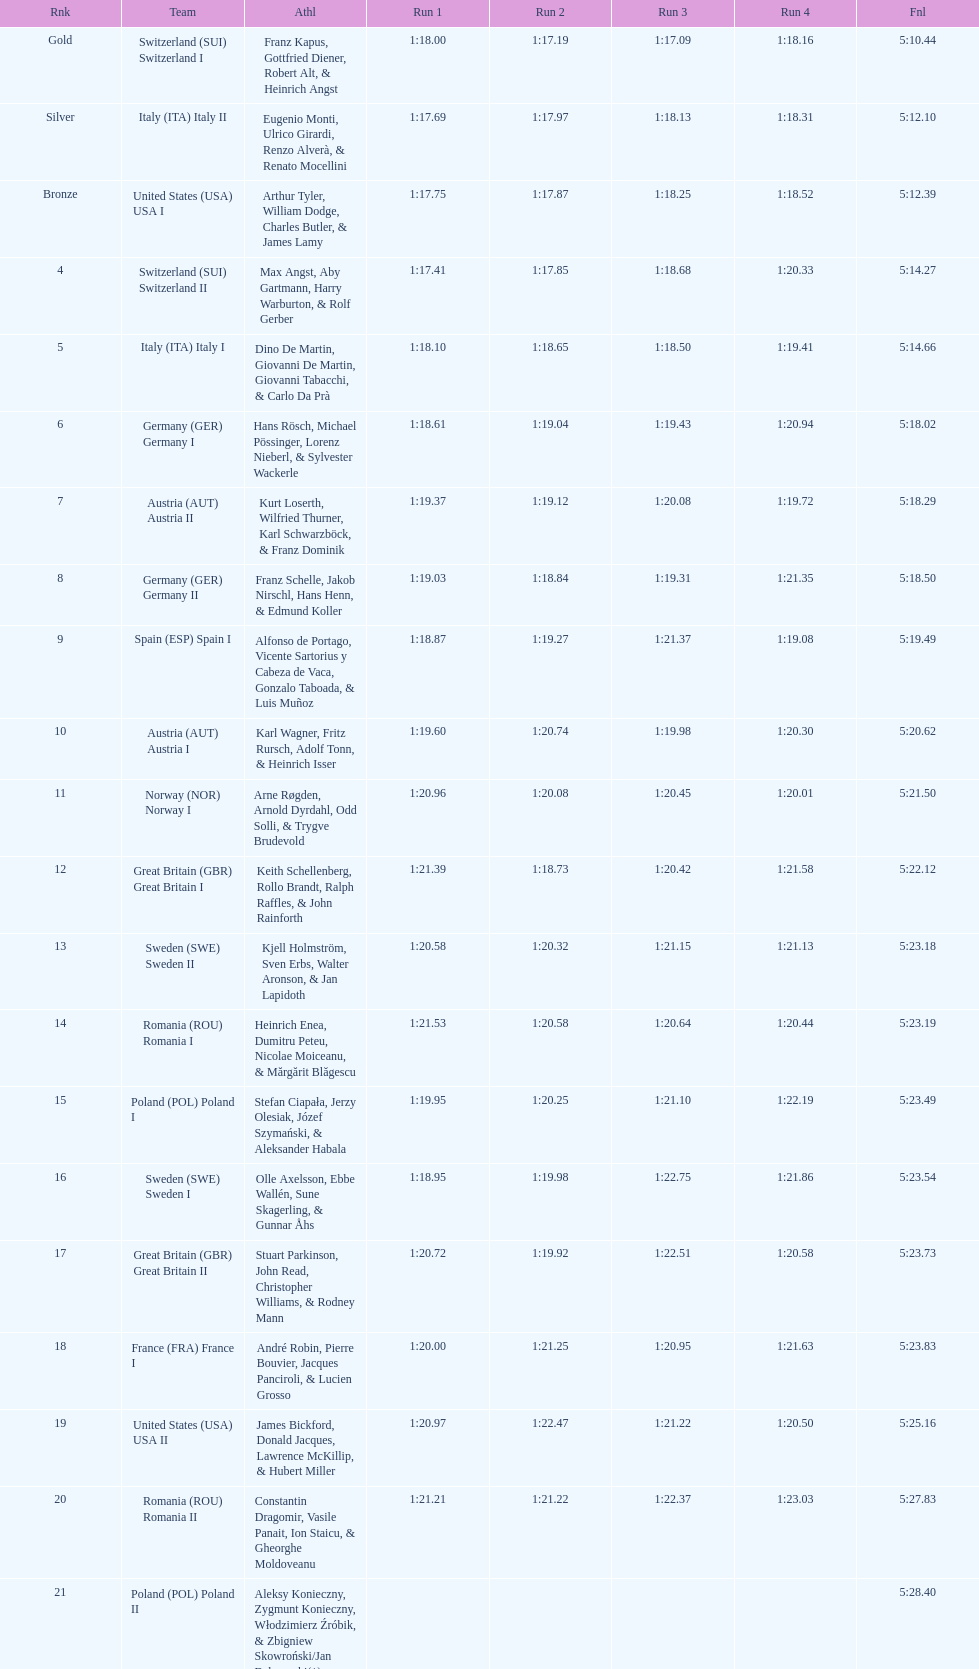How many teams did germany have? 2. 